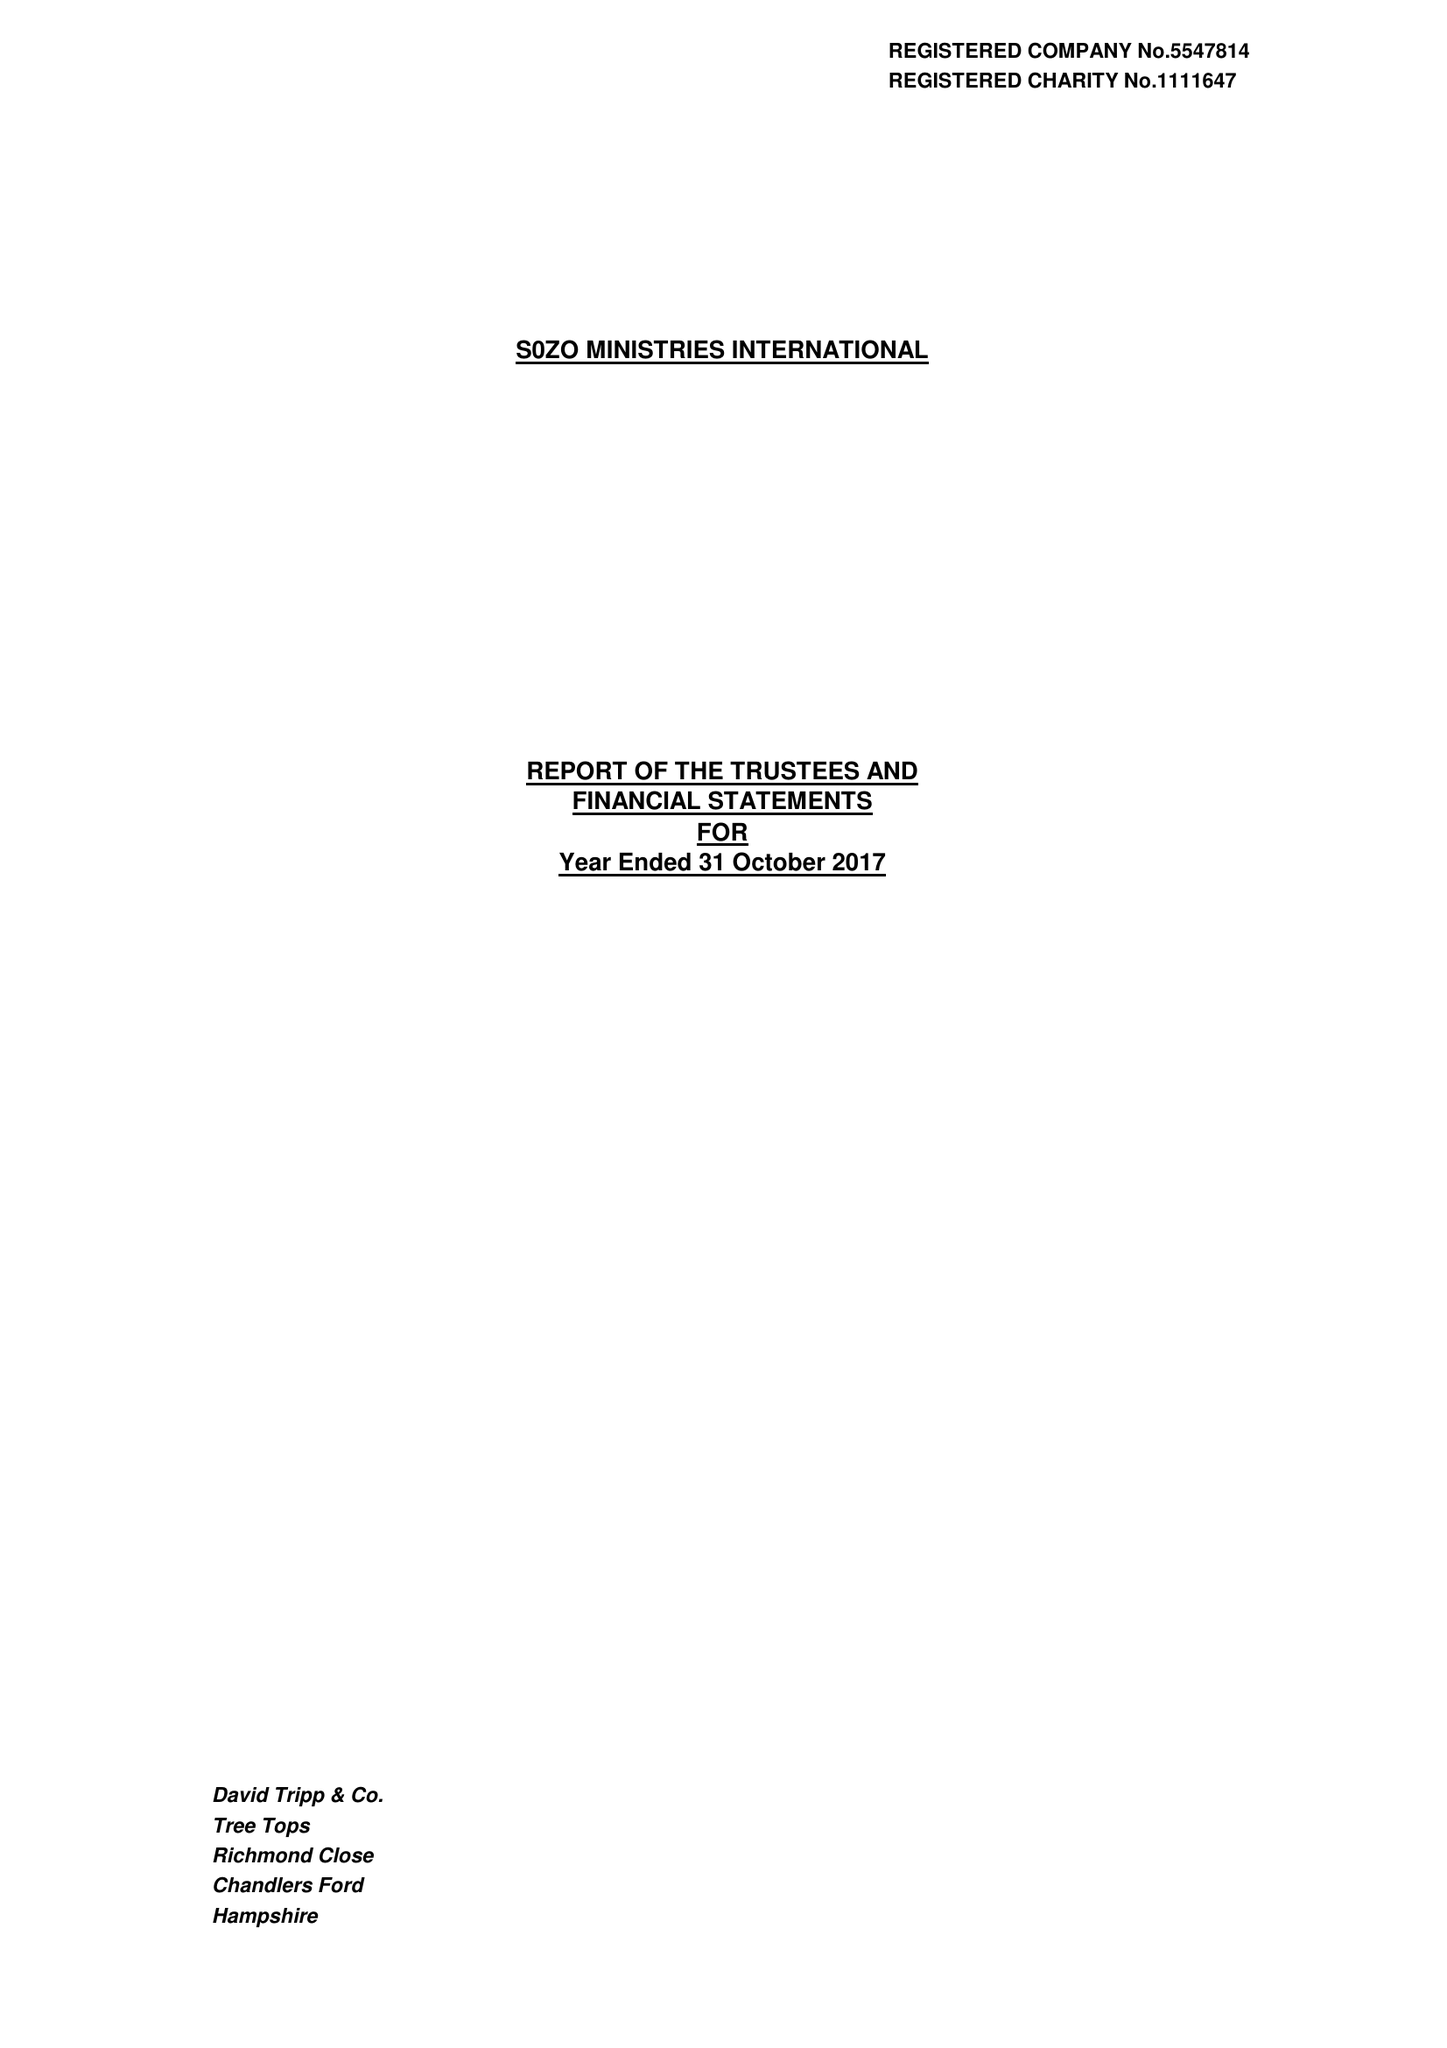What is the value for the address__street_line?
Answer the question using a single word or phrase. DANES ROAD 